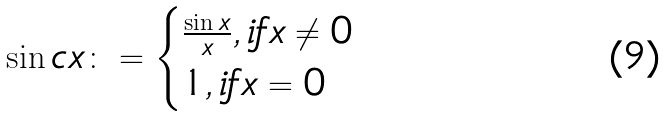<formula> <loc_0><loc_0><loc_500><loc_500>\sin c { x } \colon = \begin{cases} \frac { \sin { x } } { x } , i f x \neq 0 \\ 1 , i f x = 0 \end{cases}</formula> 